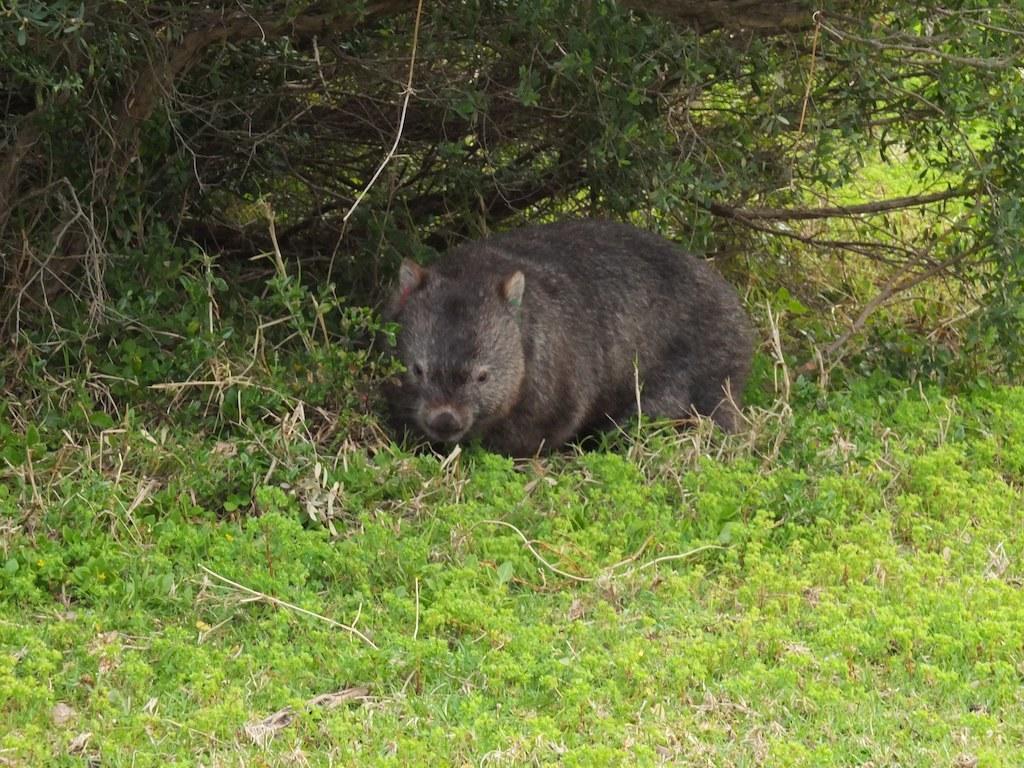In one or two sentences, can you explain what this image depicts? In this image I can see an animal which is cream and black in color is on the ground. I can see some grass which is green in color and few trees. 